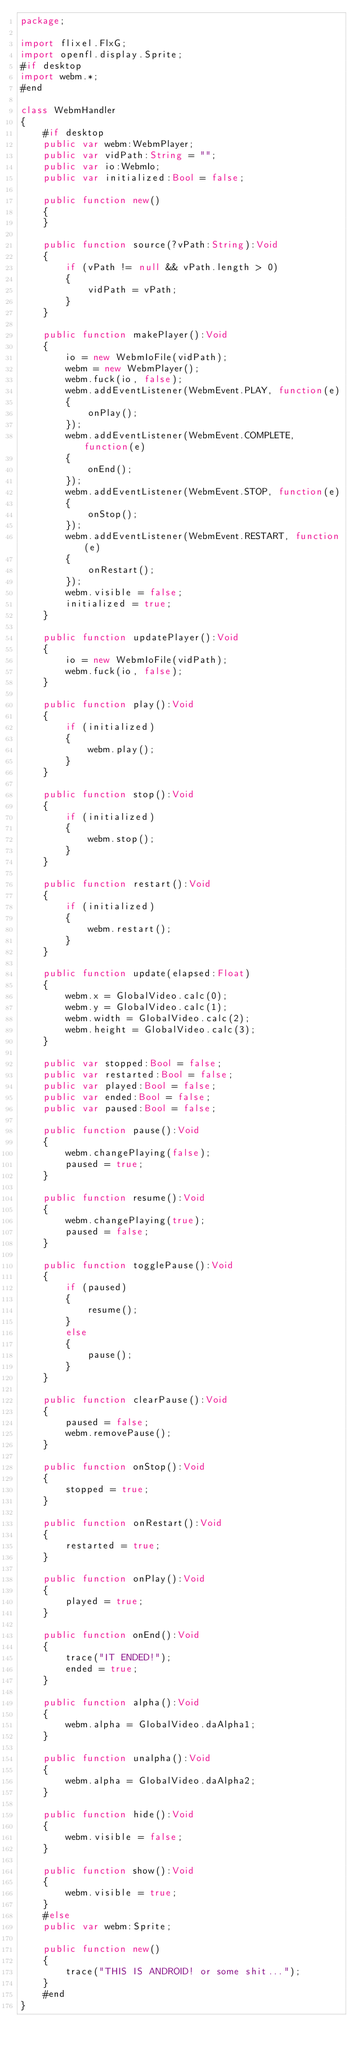Convert code to text. <code><loc_0><loc_0><loc_500><loc_500><_Haxe_>package;

import flixel.FlxG;
import openfl.display.Sprite;
#if desktop
import webm.*;
#end

class WebmHandler
{
	#if desktop
	public var webm:WebmPlayer;
	public var vidPath:String = "";
	public var io:WebmIo;
	public var initialized:Bool = false;

	public function new()
	{
	}

	public function source(?vPath:String):Void
	{
		if (vPath != null && vPath.length > 0)
		{
			vidPath = vPath;
		}
	}

	public function makePlayer():Void
	{
		io = new WebmIoFile(vidPath);
		webm = new WebmPlayer();
		webm.fuck(io, false);
		webm.addEventListener(WebmEvent.PLAY, function(e)
		{
			onPlay();
		});
		webm.addEventListener(WebmEvent.COMPLETE, function(e)
		{
			onEnd();
		});
		webm.addEventListener(WebmEvent.STOP, function(e)
		{
			onStop();
		});
		webm.addEventListener(WebmEvent.RESTART, function(e)
		{
			onRestart();
		});
		webm.visible = false;
		initialized = true;
	}

	public function updatePlayer():Void
	{
		io = new WebmIoFile(vidPath);
		webm.fuck(io, false);
	}

	public function play():Void
	{
		if (initialized)
		{
			webm.play();
		}
	}

	public function stop():Void
	{
		if (initialized)
		{
			webm.stop();
		}
	}

	public function restart():Void
	{
		if (initialized)
		{
			webm.restart();
		}
	}

	public function update(elapsed:Float)
	{
		webm.x = GlobalVideo.calc(0);
		webm.y = GlobalVideo.calc(1);
		webm.width = GlobalVideo.calc(2);
		webm.height = GlobalVideo.calc(3);
	}

	public var stopped:Bool = false;
	public var restarted:Bool = false;
	public var played:Bool = false;
	public var ended:Bool = false;
	public var paused:Bool = false;

	public function pause():Void
	{
		webm.changePlaying(false);
		paused = true;
	}

	public function resume():Void
	{
		webm.changePlaying(true);
		paused = false;
	}

	public function togglePause():Void
	{
		if (paused)
		{
			resume();
		}
		else
		{
			pause();
		}
	}

	public function clearPause():Void
	{
		paused = false;
		webm.removePause();
	}

	public function onStop():Void
	{
		stopped = true;
	}

	public function onRestart():Void
	{
		restarted = true;
	}

	public function onPlay():Void
	{
		played = true;
	}

	public function onEnd():Void
	{
		trace("IT ENDED!");
		ended = true;
	}

	public function alpha():Void
	{
		webm.alpha = GlobalVideo.daAlpha1;
	}

	public function unalpha():Void
	{
		webm.alpha = GlobalVideo.daAlpha2;
	}

	public function hide():Void
	{
		webm.visible = false;
	}

	public function show():Void
	{
		webm.visible = true;
	}
	#else
	public var webm:Sprite;

	public function new()
	{
		trace("THIS IS ANDROID! or some shit...");
	}
	#end
}
</code> 